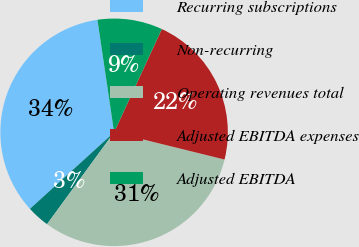Convert chart. <chart><loc_0><loc_0><loc_500><loc_500><pie_chart><fcel>Recurring subscriptions<fcel>Non-recurring<fcel>Operating revenues total<fcel>Adjusted EBITDA expenses<fcel>Adjusted EBITDA<nl><fcel>34.41%<fcel>3.22%<fcel>31.19%<fcel>21.96%<fcel>9.23%<nl></chart> 